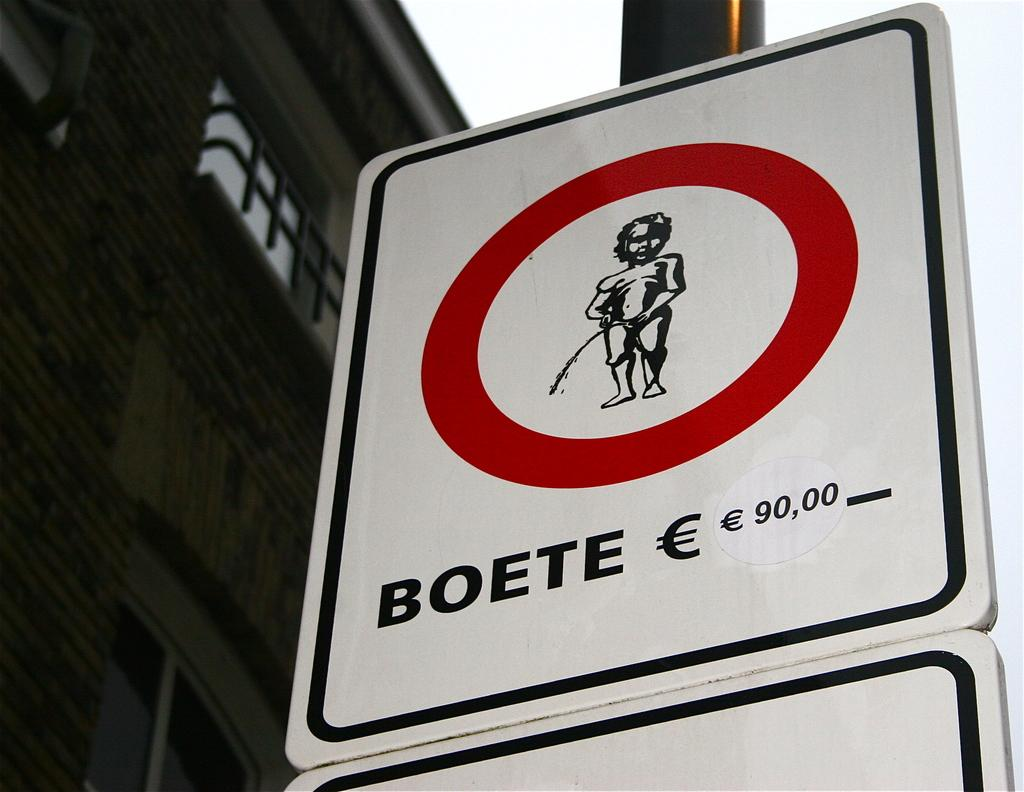<image>
Present a compact description of the photo's key features. A sign that says Boete shows a young boy urinating in a red circle 